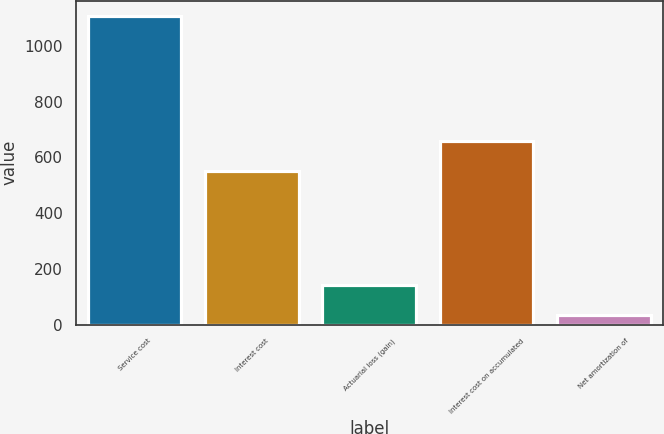Convert chart. <chart><loc_0><loc_0><loc_500><loc_500><bar_chart><fcel>Service cost<fcel>Interest cost<fcel>Actuarial loss (gain)<fcel>Interest cost on accumulated<fcel>Net amortization of<nl><fcel>1107<fcel>553<fcel>142.2<fcel>660.2<fcel>35<nl></chart> 